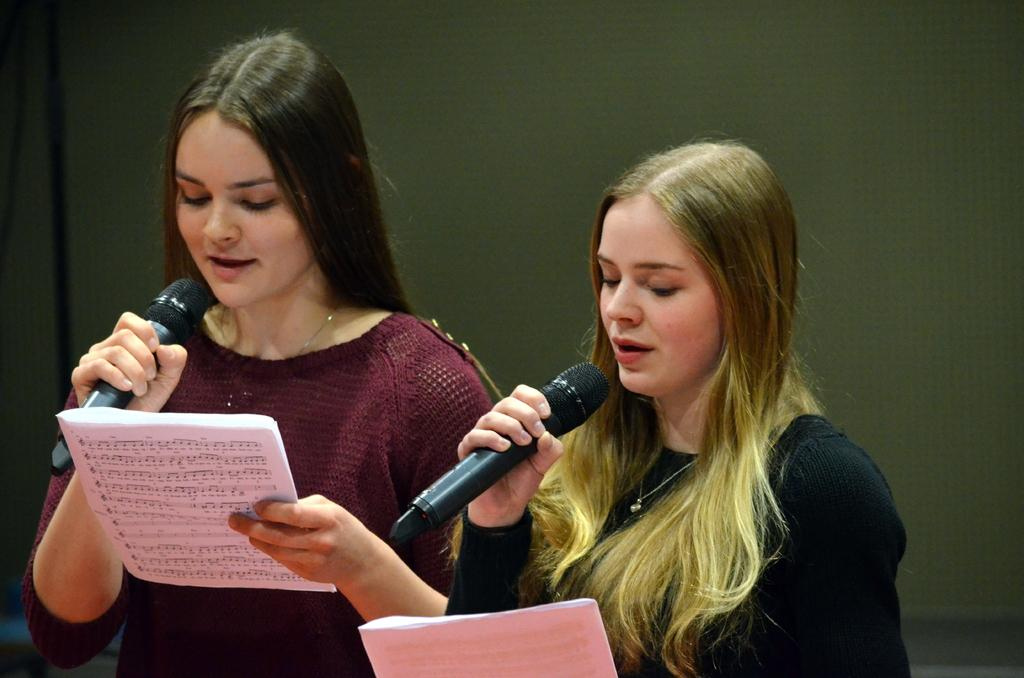How many people are in the image? There are two persons in the image. What are the persons wearing? The persons are wearing colorful clothes. What are the persons holding in their hands? The persons are holding a mic and a paper. What type of meal is being prepared in the image? There is no meal preparation visible in the image; it features two persons holding a mic and a paper. What type of card is being used by the persons in the image? There is no card present in the image; the persons are holding a mic and a paper. 